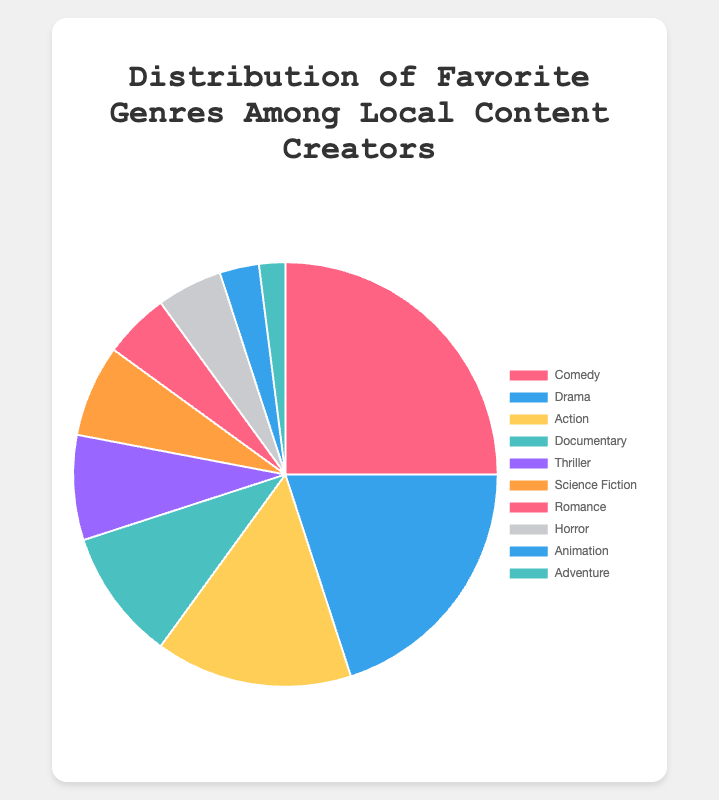Which genre is the most popular among the local content creators? According to the data, Comedy has the highest percentage with 25%.
Answer: Comedy Which genres are equally popular among the local content creators? Both Romance and Horror have the same percentage of 5%.
Answer: Romance and Horror What is the sum of the percentages for Drama and Action genres? Drama is 20% and Action is 15%, so their sum is 20% + 15% = 35%.
Answer: 35% How does the popularity of Documentary compare to that of Science Fiction? Documentary is at 10%, while Science Fiction is at 7%. Documentary is more popular than Science Fiction.
Answer: Documentary is more popular What is the average percentage of the Adventure, Animation, and Horror genres? Adventure has 2%, Animation has 3%, and Horror has 5%. The sum is 2% + 3% + 5% = 10%. The average is 10% / 3 = 3.33%.
Answer: 3.33% Which genre holds exactly half the percentage of the most popular genre? The most popular genre is Comedy with 25%. Half of 25% is 12.5%. Thriller is closest with 8%, but no genre exactly holds half of Comedy's percentage.
Answer: None Which genre has a percentage just below the percentage of Thriller? Thriller has 8%. The genre just below this percentage is Science Fiction with 7%.
Answer: Science Fiction Compare the combined percentage of Comedy, Drama, and Action with the combined percentage of Documentary, Thriller, and Science Fiction. Which is higher? Comedy, Drama, and Action combined add up to 25% + 20% + 15% = 60%. Documentary, Thriller, and Science Fiction combined add up to 10% + 8% + 7% = 25%. The first combination is higher.
Answer: Comedy, Drama, and Action combination What is the total percentage of genres less popular than Thriller? The percentages for genres less popular than Thriller (8%) are Science Fiction (7%), Romance (5%), Horror (5%), Animation (3%), and Adventure (2%). Their total is 7% + 5% + 5% + 3% + 2% = 22%.
Answer: 22% What is the difference between the percentages of the Comedy and the least popular genre? Comedy has 25% and Adventure has the least with 2%. The difference is 25% - 2% = 23%.
Answer: 23% 